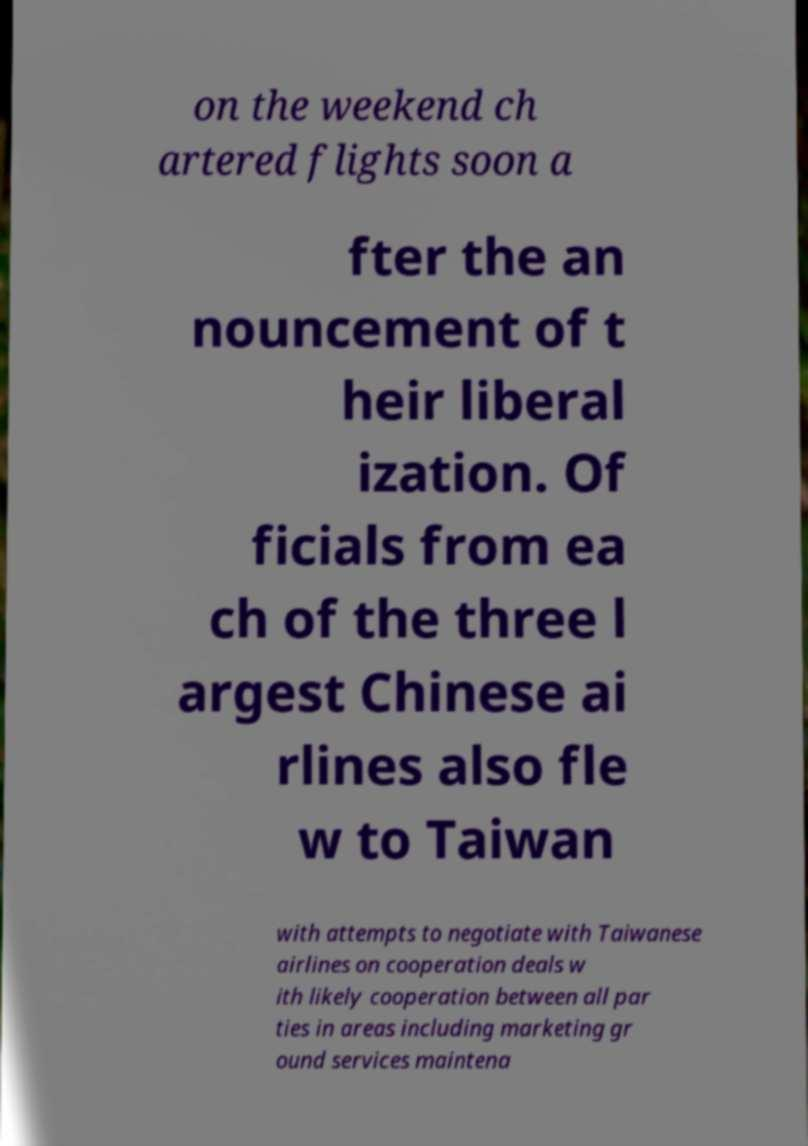I need the written content from this picture converted into text. Can you do that? on the weekend ch artered flights soon a fter the an nouncement of t heir liberal ization. Of ficials from ea ch of the three l argest Chinese ai rlines also fle w to Taiwan with attempts to negotiate with Taiwanese airlines on cooperation deals w ith likely cooperation between all par ties in areas including marketing gr ound services maintena 